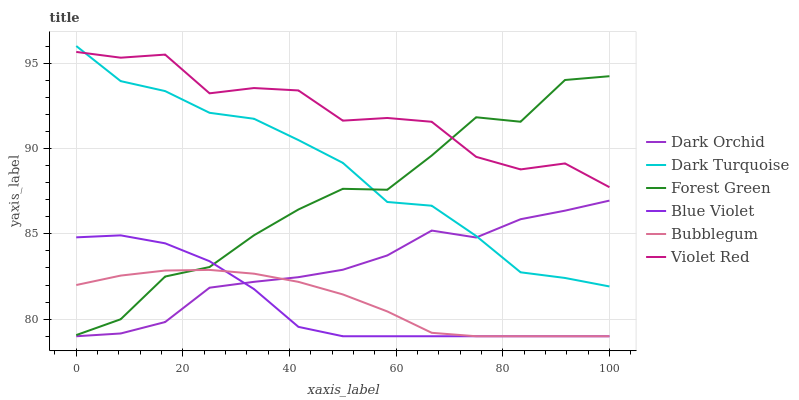Does Dark Turquoise have the minimum area under the curve?
Answer yes or no. No. Does Dark Turquoise have the maximum area under the curve?
Answer yes or no. No. Is Dark Turquoise the smoothest?
Answer yes or no. No. Is Dark Turquoise the roughest?
Answer yes or no. No. Does Dark Turquoise have the lowest value?
Answer yes or no. No. Does Bubblegum have the highest value?
Answer yes or no. No. Is Bubblegum less than Dark Turquoise?
Answer yes or no. Yes. Is Forest Green greater than Dark Orchid?
Answer yes or no. Yes. Does Bubblegum intersect Dark Turquoise?
Answer yes or no. No. 